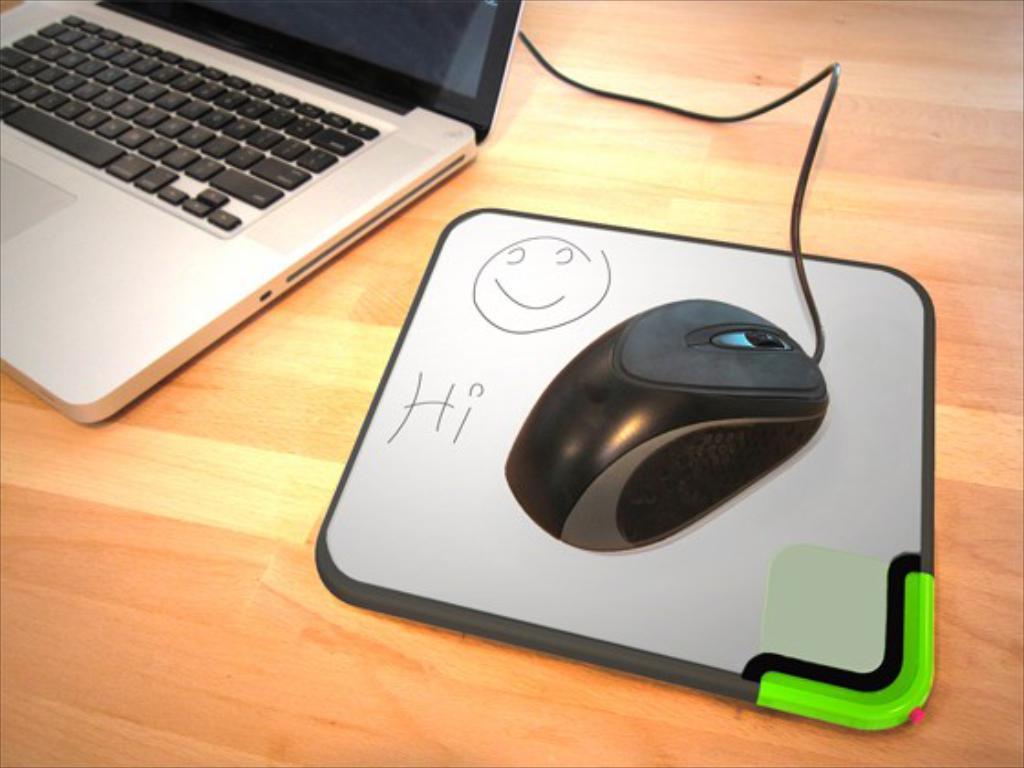Please provide a concise description of this image. In the image in the center we can see one table. On the table,there is a laptop,mouse and one white and black color object. 